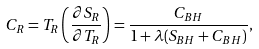<formula> <loc_0><loc_0><loc_500><loc_500>C _ { R } = T _ { R } \left ( \frac { \partial S _ { R } } { \partial T _ { R } } \right ) = \frac { C _ { B H } } { 1 + \lambda ( S _ { B H } + C _ { B H } ) } ,</formula> 